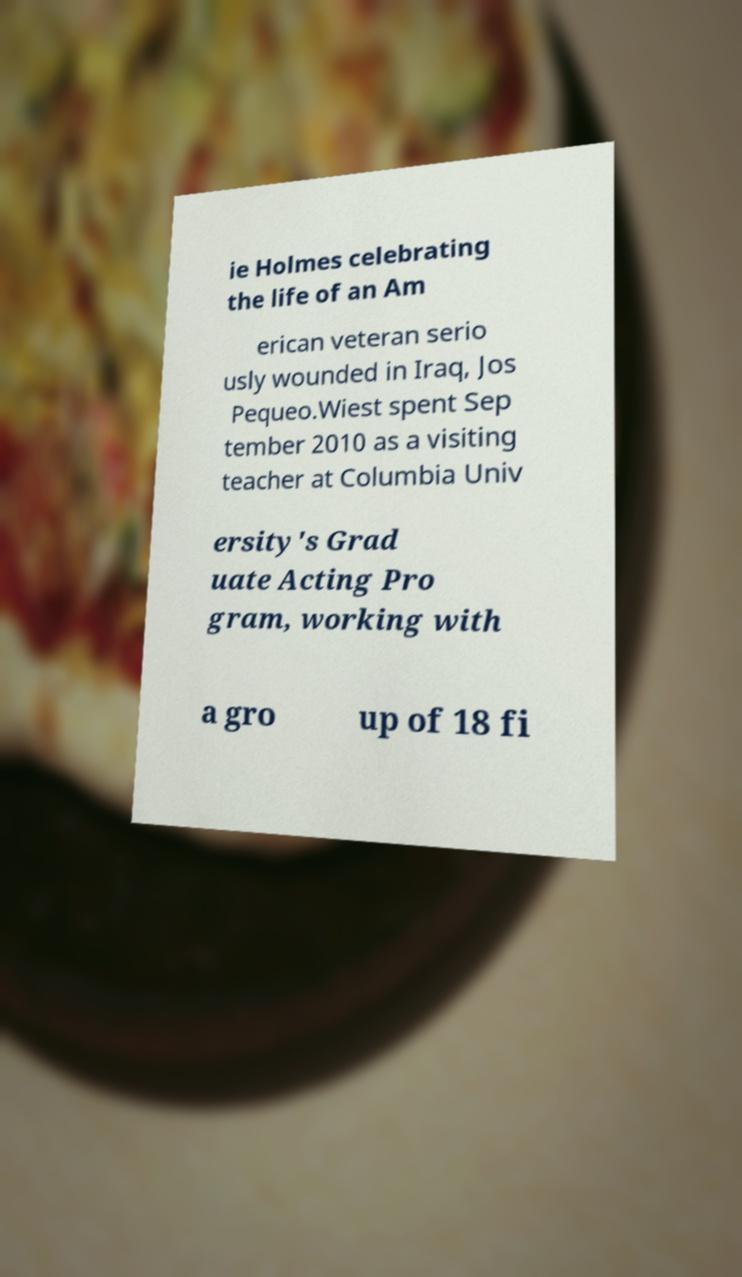Please identify and transcribe the text found in this image. ie Holmes celebrating the life of an Am erican veteran serio usly wounded in Iraq, Jos Pequeo.Wiest spent Sep tember 2010 as a visiting teacher at Columbia Univ ersity's Grad uate Acting Pro gram, working with a gro up of 18 fi 